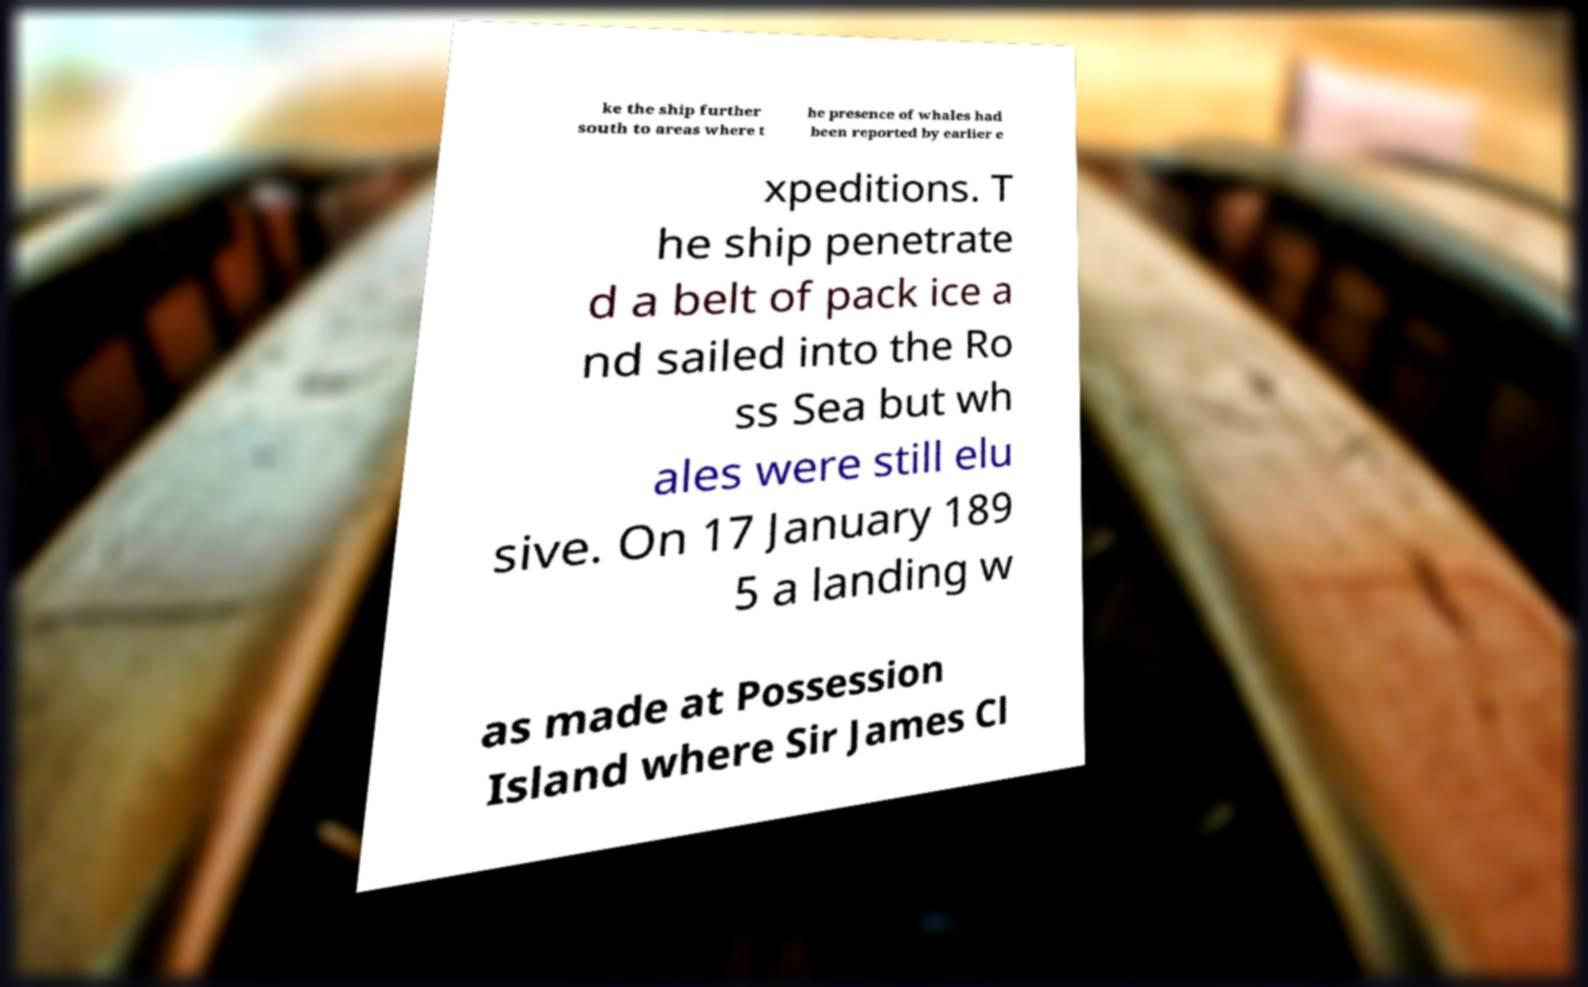Can you accurately transcribe the text from the provided image for me? ke the ship further south to areas where t he presence of whales had been reported by earlier e xpeditions. T he ship penetrate d a belt of pack ice a nd sailed into the Ro ss Sea but wh ales were still elu sive. On 17 January 189 5 a landing w as made at Possession Island where Sir James Cl 